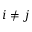Convert formula to latex. <formula><loc_0><loc_0><loc_500><loc_500>i \ne j</formula> 